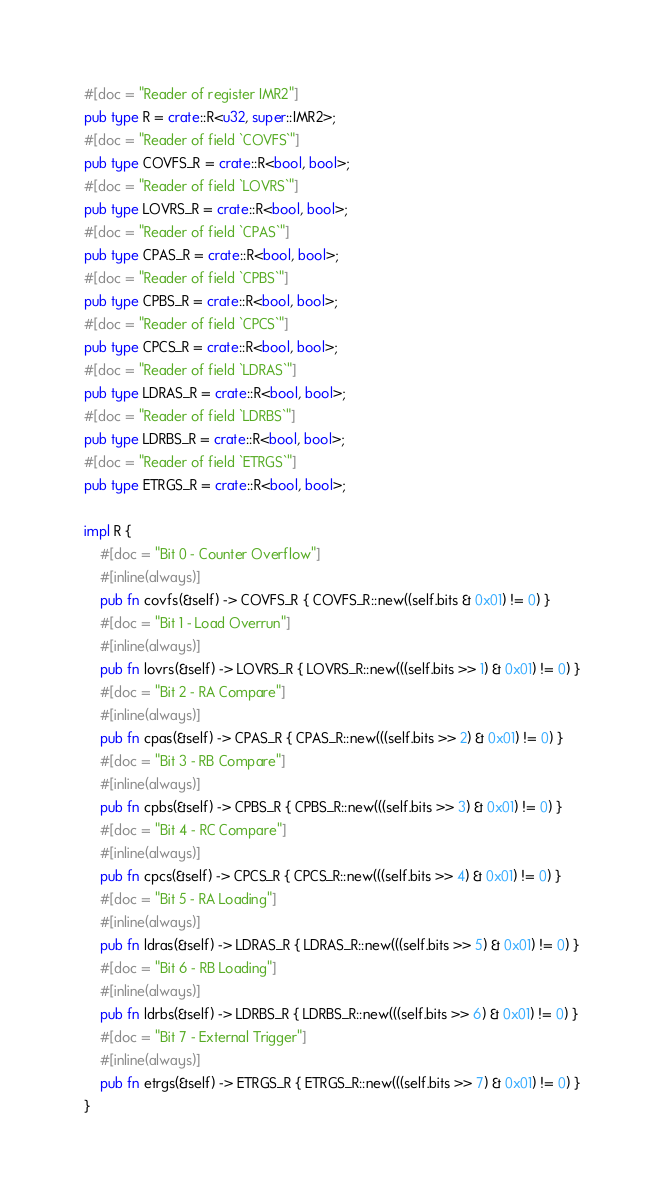Convert code to text. <code><loc_0><loc_0><loc_500><loc_500><_Rust_>#[doc = "Reader of register IMR2"]
pub type R = crate::R<u32, super::IMR2>;
#[doc = "Reader of field `COVFS`"]
pub type COVFS_R = crate::R<bool, bool>;
#[doc = "Reader of field `LOVRS`"]
pub type LOVRS_R = crate::R<bool, bool>;
#[doc = "Reader of field `CPAS`"]
pub type CPAS_R = crate::R<bool, bool>;
#[doc = "Reader of field `CPBS`"]
pub type CPBS_R = crate::R<bool, bool>;
#[doc = "Reader of field `CPCS`"]
pub type CPCS_R = crate::R<bool, bool>;
#[doc = "Reader of field `LDRAS`"]
pub type LDRAS_R = crate::R<bool, bool>;
#[doc = "Reader of field `LDRBS`"]
pub type LDRBS_R = crate::R<bool, bool>;
#[doc = "Reader of field `ETRGS`"]
pub type ETRGS_R = crate::R<bool, bool>;

impl R {
    #[doc = "Bit 0 - Counter Overflow"]
    #[inline(always)]
    pub fn covfs(&self) -> COVFS_R { COVFS_R::new((self.bits & 0x01) != 0) }
    #[doc = "Bit 1 - Load Overrun"]
    #[inline(always)]
    pub fn lovrs(&self) -> LOVRS_R { LOVRS_R::new(((self.bits >> 1) & 0x01) != 0) }
    #[doc = "Bit 2 - RA Compare"]
    #[inline(always)]
    pub fn cpas(&self) -> CPAS_R { CPAS_R::new(((self.bits >> 2) & 0x01) != 0) }
    #[doc = "Bit 3 - RB Compare"]
    #[inline(always)]
    pub fn cpbs(&self) -> CPBS_R { CPBS_R::new(((self.bits >> 3) & 0x01) != 0) }
    #[doc = "Bit 4 - RC Compare"]
    #[inline(always)]
    pub fn cpcs(&self) -> CPCS_R { CPCS_R::new(((self.bits >> 4) & 0x01) != 0) }
    #[doc = "Bit 5 - RA Loading"]
    #[inline(always)]
    pub fn ldras(&self) -> LDRAS_R { LDRAS_R::new(((self.bits >> 5) & 0x01) != 0) }
    #[doc = "Bit 6 - RB Loading"]
    #[inline(always)]
    pub fn ldrbs(&self) -> LDRBS_R { LDRBS_R::new(((self.bits >> 6) & 0x01) != 0) }
    #[doc = "Bit 7 - External Trigger"]
    #[inline(always)]
    pub fn etrgs(&self) -> ETRGS_R { ETRGS_R::new(((self.bits >> 7) & 0x01) != 0) }
}</code> 